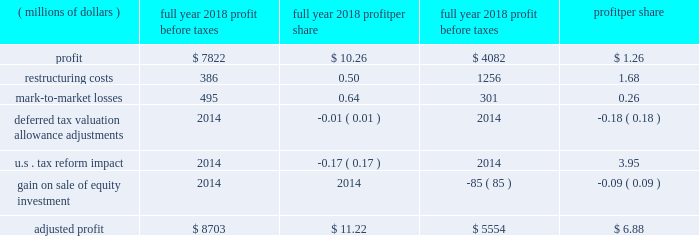2018 a0form 10-k18 item 7 .
Management 2019s discussion and analysis of financial condition and results of operations .
This management 2019s discussion and analysis of financial condition and results of operations should be read in conjunction with our discussion of cautionary statements and significant risks to the company 2019s business under item 1a .
Risk factors of the 2018 form a010-k .
Overview our sales and revenues for 2018 were $ 54.722 billion , a 20 a0percent increase from 2017 sales and revenues of $ 45.462 a0billion .
The increase was primarily due to higher sales volume , mostly due to improved demand across all regions and across the three primary segments .
Profit per share for 2018 was $ 10.26 , compared to profit per share of $ 1.26 in 2017 .
Profit was $ 6.147 billion in 2018 , compared with $ 754 million in 2017 .
The increase was primarily due to lower tax expense , higher sales volume , decreased restructuring costs and improved price realization .
The increase was partially offset by higher manufacturing costs and selling , general and administrative ( sg&a ) and research and development ( r&d ) expenses and lower profit from the financial products segment .
Fourth-quarter 2018 sales and revenues were $ 14.342 billion , up $ 1.446 billion , or 11 percent , from $ 12.896 billion in the fourth quarter of 2017 .
Fourth-quarter 2018 profit was $ 1.78 per share , compared with a loss of $ 2.18 per share in the fourth quarter of 2017 .
Fourth-quarter 2018 profit was $ 1.048 billion , compared with a loss of $ 1.299 billion in 2017 .
Highlights for 2018 include : zz sales and revenues in 2018 were $ 54.722 billion , up 20 a0percent from 2017 .
Sales improved in all regions and across the three primary segments .
Zz operating profit as a percent of sales and revenues was 15.2 a0percent in 2018 , compared with 9.8 percent in 2017 .
Adjusted operating profit margin was 15.9 percent in 2018 , compared with 12.5 percent in 2017 .
Zz profit was $ 10.26 per share for 2018 , and excluding the items in the table below , adjusted profit per share was $ 11.22 .
For 2017 profit was $ 1.26 per share , and excluding the items in the table below , adjusted profit per share was $ 6.88 .
Zz in order for our results to be more meaningful to our readers , we have separately quantified the impact of several significant items: .
Zz machinery , energy & transportation ( me&t ) operating cash flow for 2018 was about $ 6.3 billion , more than sufficient to cover capital expenditures and dividends .
Me&t operating cash flow for 2017 was about $ 5.5 billion .
Restructuring costs in recent years , we have incurred substantial restructuring costs to achieve a flexible and competitive cost structure .
During 2018 , we incurred $ 386 million of restructuring costs related to restructuring actions across the company .
During 2017 , we incurred $ 1.256 billion of restructuring costs with about half related to the closure of the facility in gosselies , belgium , and the remainder related to other restructuring actions across the company .
Although we expect restructuring to continue as part of ongoing business activities , restructuring costs should be lower in 2019 than 2018 .
Notes : zz glossary of terms included on pages 33-34 ; first occurrence of terms shown in bold italics .
Zz information on non-gaap financial measures is included on pages 42-43. .
What was the growth rate for the machinery , energy & transportation ( me&t ) operating cash flow in 2018? 
Computations: (6.3 / 5.5)
Answer: 1.14545. 